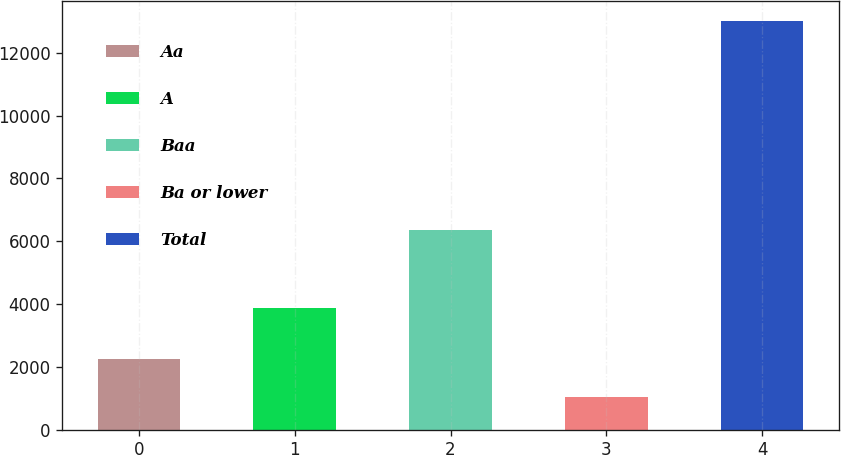Convert chart to OTSL. <chart><loc_0><loc_0><loc_500><loc_500><bar_chart><fcel>Aa<fcel>A<fcel>Baa<fcel>Ba or lower<fcel>Total<nl><fcel>2237.8<fcel>3873<fcel>6361<fcel>1041<fcel>13009<nl></chart> 